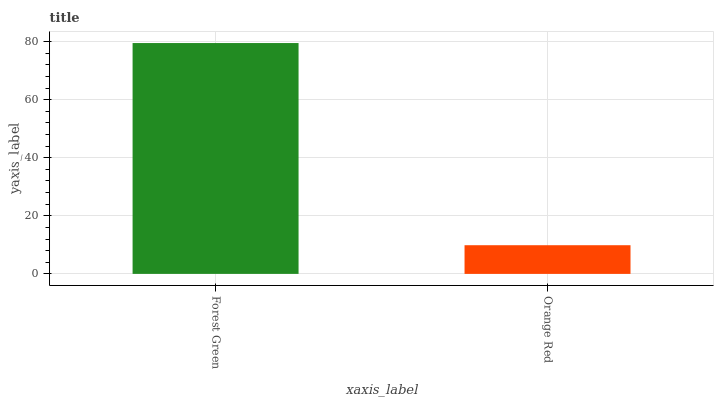Is Orange Red the minimum?
Answer yes or no. Yes. Is Forest Green the maximum?
Answer yes or no. Yes. Is Orange Red the maximum?
Answer yes or no. No. Is Forest Green greater than Orange Red?
Answer yes or no. Yes. Is Orange Red less than Forest Green?
Answer yes or no. Yes. Is Orange Red greater than Forest Green?
Answer yes or no. No. Is Forest Green less than Orange Red?
Answer yes or no. No. Is Forest Green the high median?
Answer yes or no. Yes. Is Orange Red the low median?
Answer yes or no. Yes. Is Orange Red the high median?
Answer yes or no. No. Is Forest Green the low median?
Answer yes or no. No. 